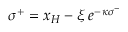<formula> <loc_0><loc_0><loc_500><loc_500>\, \sigma ^ { + } = x _ { H } - \xi \, e ^ { - \, \kappa \sigma ^ { - } } \,</formula> 